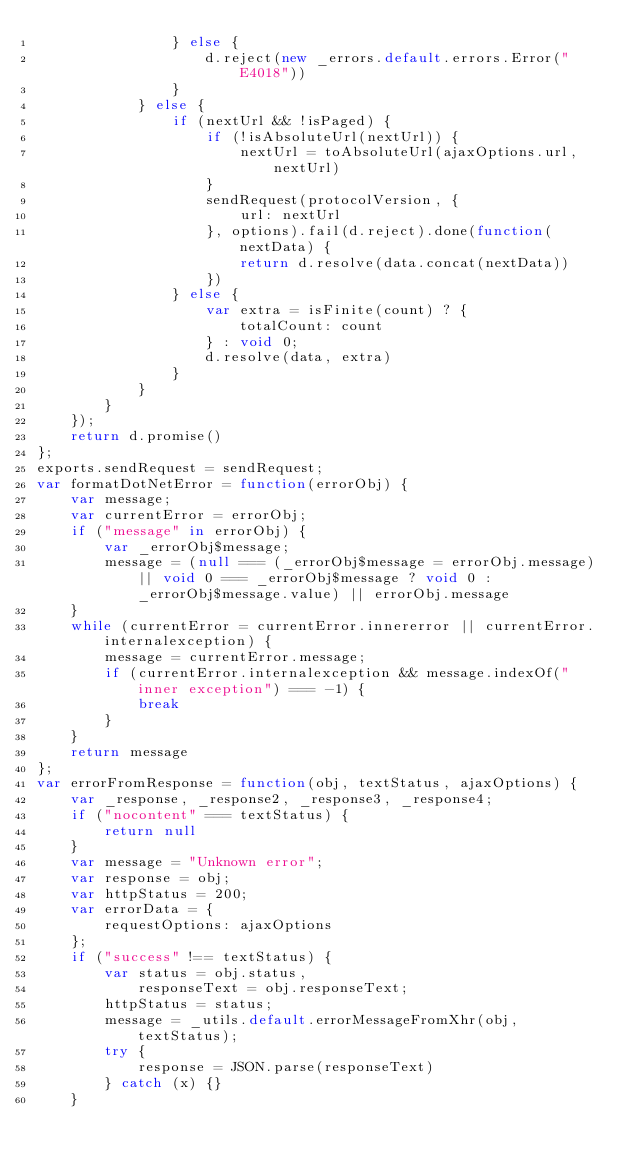Convert code to text. <code><loc_0><loc_0><loc_500><loc_500><_JavaScript_>                } else {
                    d.reject(new _errors.default.errors.Error("E4018"))
                }
            } else {
                if (nextUrl && !isPaged) {
                    if (!isAbsoluteUrl(nextUrl)) {
                        nextUrl = toAbsoluteUrl(ajaxOptions.url, nextUrl)
                    }
                    sendRequest(protocolVersion, {
                        url: nextUrl
                    }, options).fail(d.reject).done(function(nextData) {
                        return d.resolve(data.concat(nextData))
                    })
                } else {
                    var extra = isFinite(count) ? {
                        totalCount: count
                    } : void 0;
                    d.resolve(data, extra)
                }
            }
        }
    });
    return d.promise()
};
exports.sendRequest = sendRequest;
var formatDotNetError = function(errorObj) {
    var message;
    var currentError = errorObj;
    if ("message" in errorObj) {
        var _errorObj$message;
        message = (null === (_errorObj$message = errorObj.message) || void 0 === _errorObj$message ? void 0 : _errorObj$message.value) || errorObj.message
    }
    while (currentError = currentError.innererror || currentError.internalexception) {
        message = currentError.message;
        if (currentError.internalexception && message.indexOf("inner exception") === -1) {
            break
        }
    }
    return message
};
var errorFromResponse = function(obj, textStatus, ajaxOptions) {
    var _response, _response2, _response3, _response4;
    if ("nocontent" === textStatus) {
        return null
    }
    var message = "Unknown error";
    var response = obj;
    var httpStatus = 200;
    var errorData = {
        requestOptions: ajaxOptions
    };
    if ("success" !== textStatus) {
        var status = obj.status,
            responseText = obj.responseText;
        httpStatus = status;
        message = _utils.default.errorMessageFromXhr(obj, textStatus);
        try {
            response = JSON.parse(responseText)
        } catch (x) {}
    }</code> 